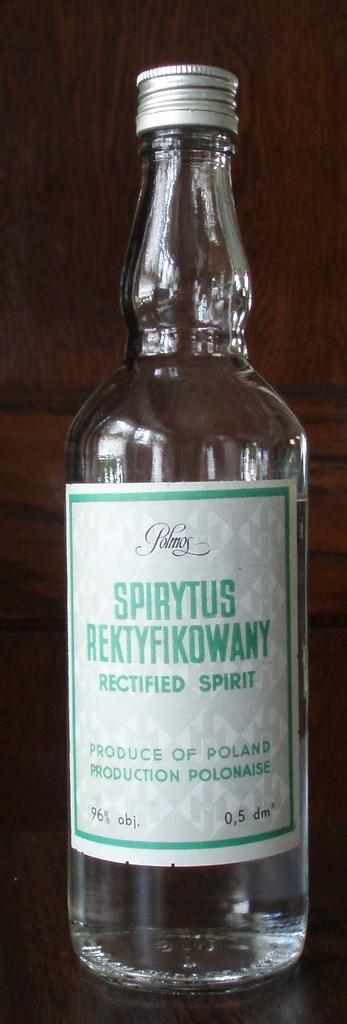<image>
Render a clear and concise summary of the photo. A close up of a bottle of polish alcohol which is clear and has an alcohol content of 96% 